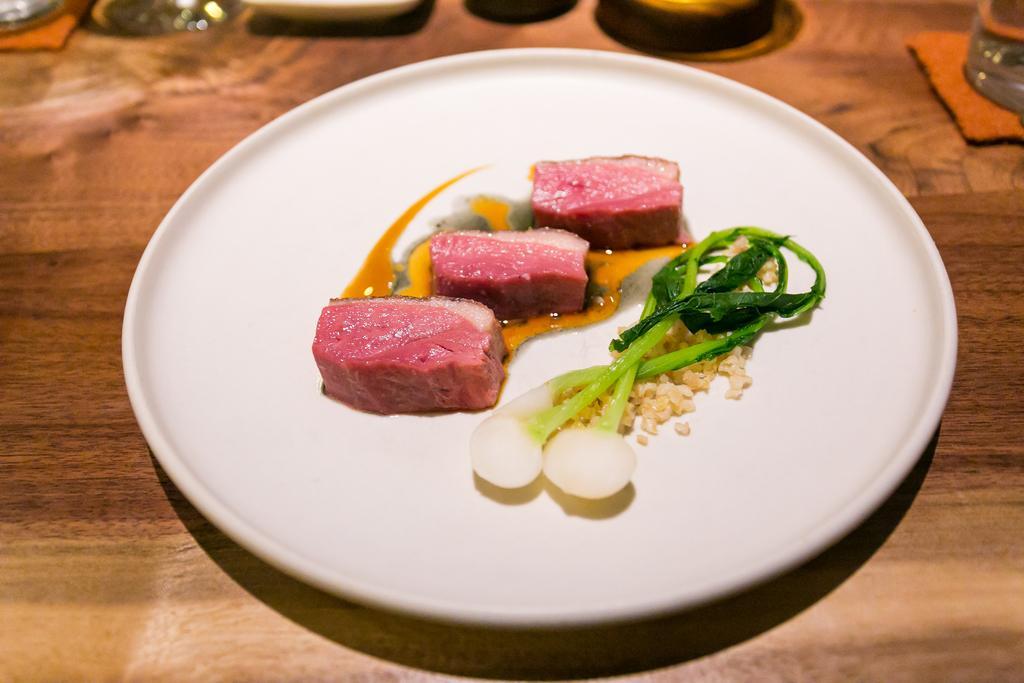What is on the plate that is visible in the image? There is food on a plate in the image. Where is the plate located in the image? The plate is on a surface in the image. What type of objects are truncated in the image? There are truncated objects in the image. Can you describe the location of the truncated object towards the right? There is an object towards the right that is truncated. What day of the week is depicted in the image? There is no indication of a specific day of the week in the image. What type of horse can be seen in the image? There are no horses present in the image. 